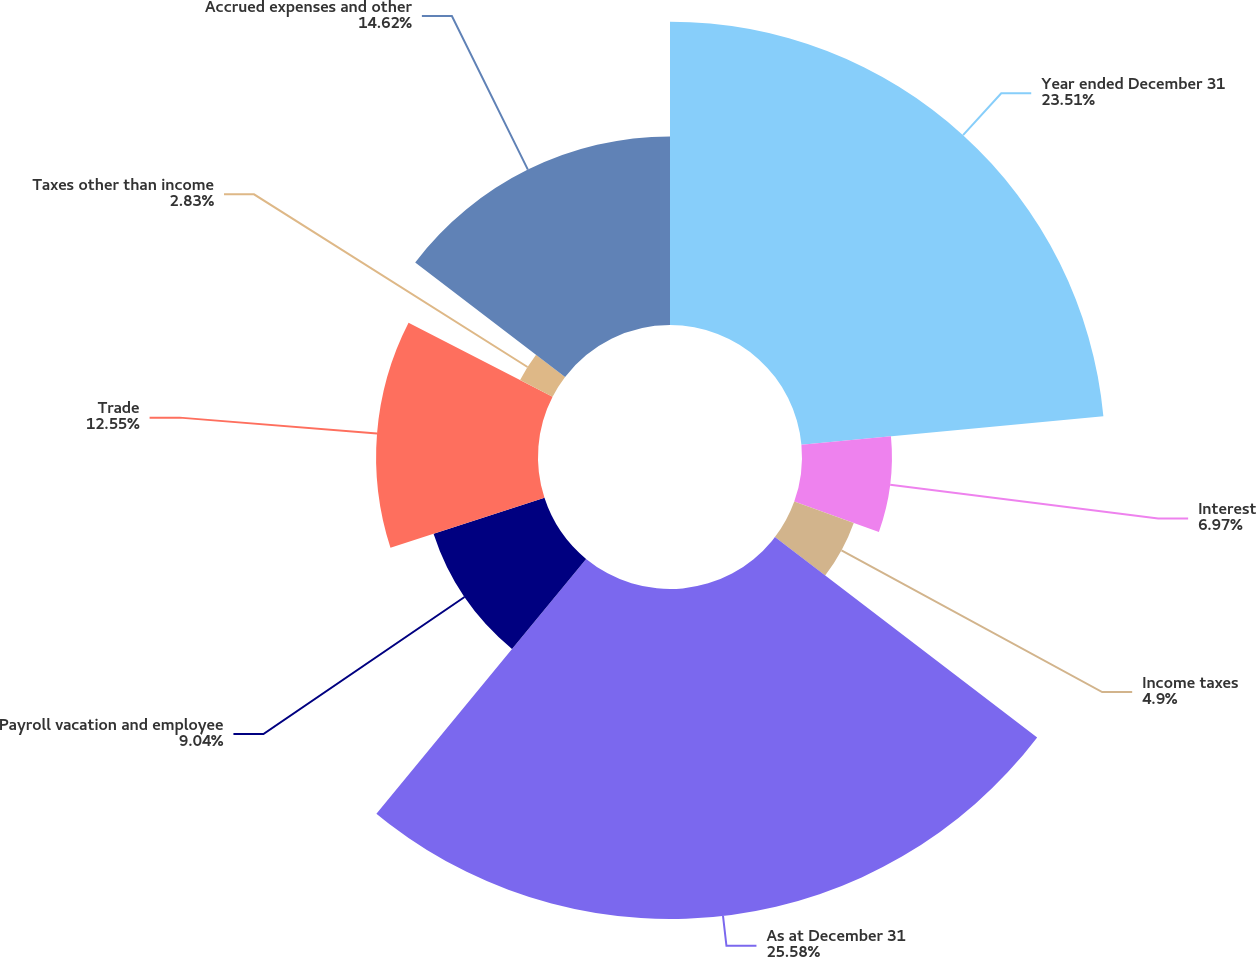Convert chart. <chart><loc_0><loc_0><loc_500><loc_500><pie_chart><fcel>Year ended December 31<fcel>Interest<fcel>Income taxes<fcel>As at December 31<fcel>Payroll vacation and employee<fcel>Trade<fcel>Taxes other than income<fcel>Accrued expenses and other<nl><fcel>23.51%<fcel>6.97%<fcel>4.9%<fcel>25.58%<fcel>9.04%<fcel>12.55%<fcel>2.83%<fcel>14.62%<nl></chart> 